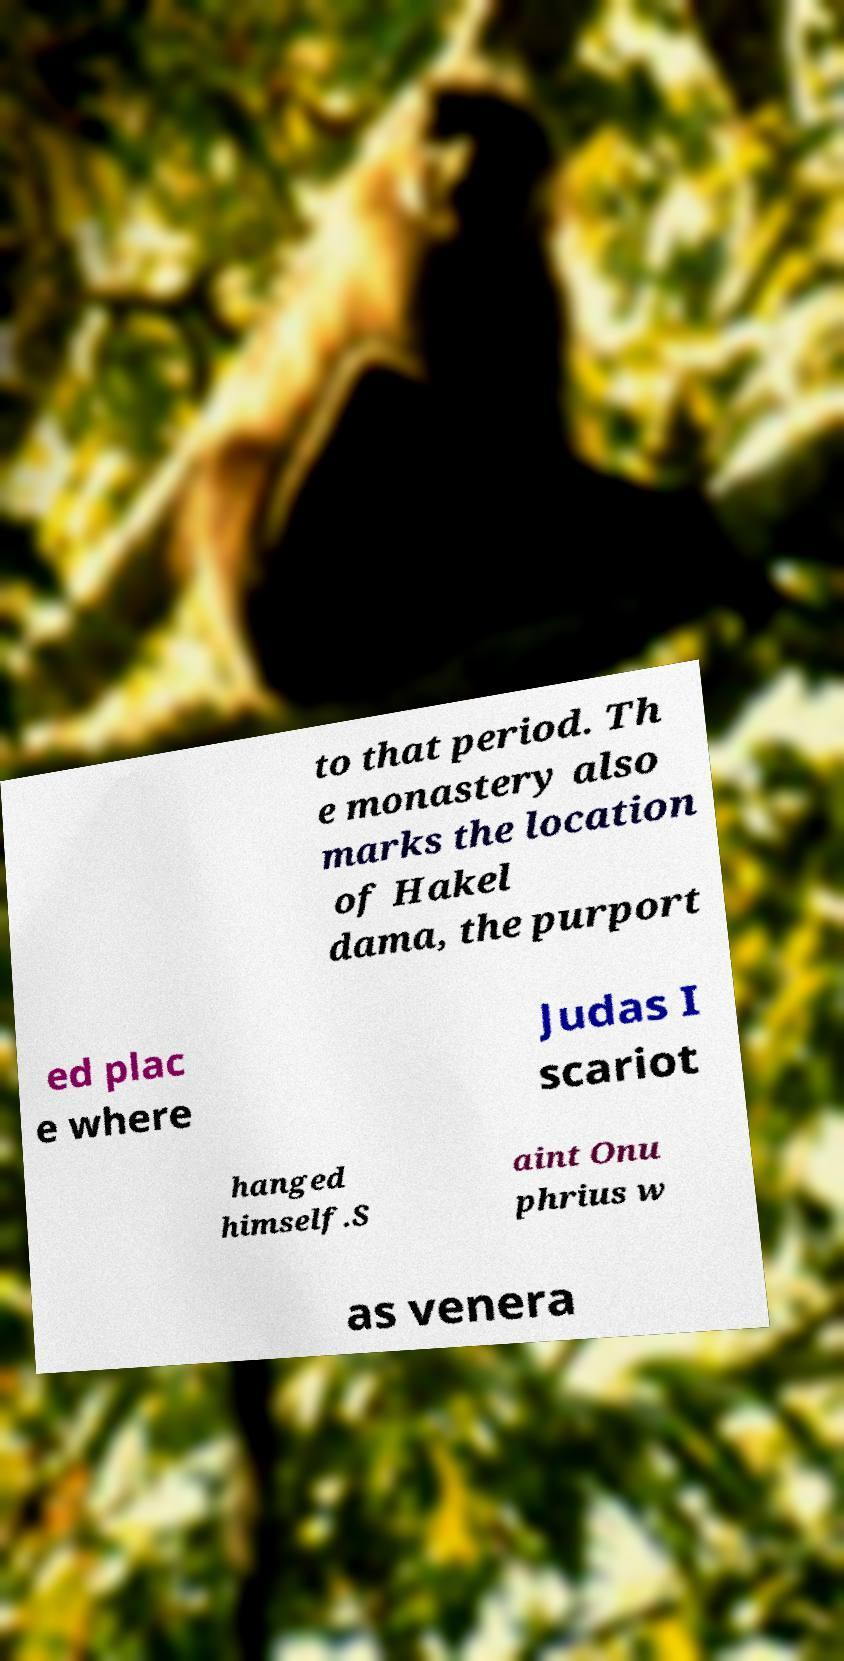Could you extract and type out the text from this image? to that period. Th e monastery also marks the location of Hakel dama, the purport ed plac e where Judas I scariot hanged himself.S aint Onu phrius w as venera 